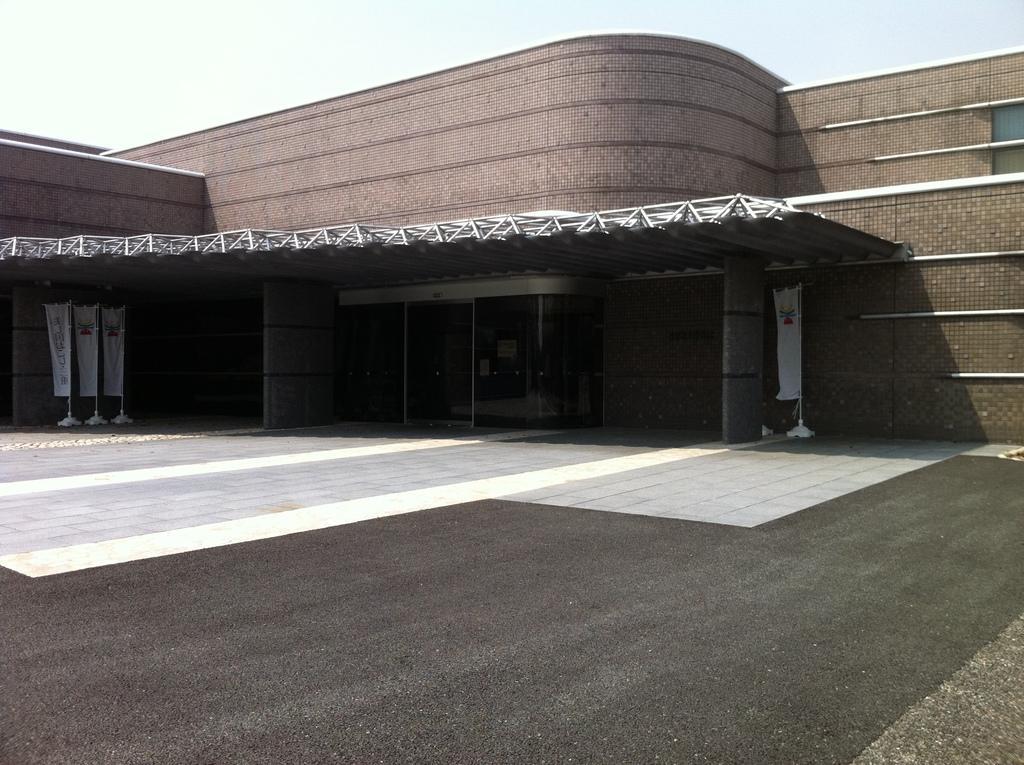Describe this image in one or two sentences. In the image there is a building in the back with road in front of it and flags on either side and above its sky. 